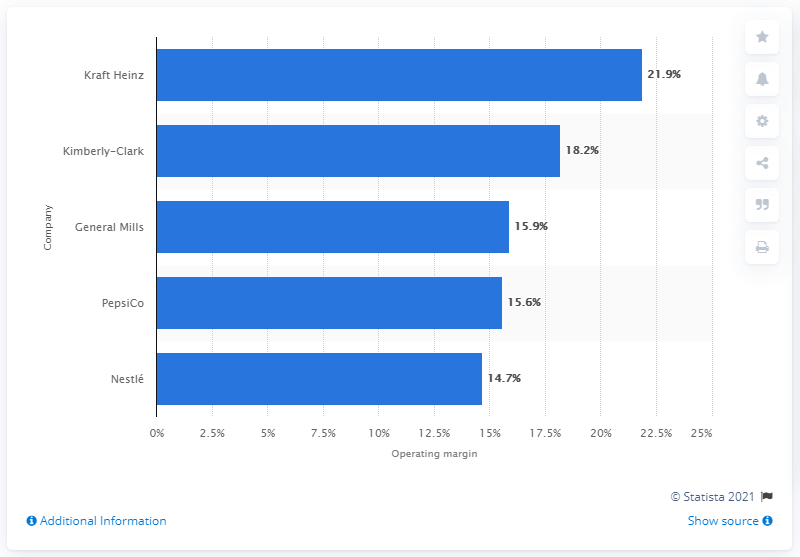Give some essential details in this illustration. In 2016, Kraft Heinz's operating margin was 21.9%. In 2016, Kraft Heinz had the highest operating margin among the CPG companies that were referenced. 